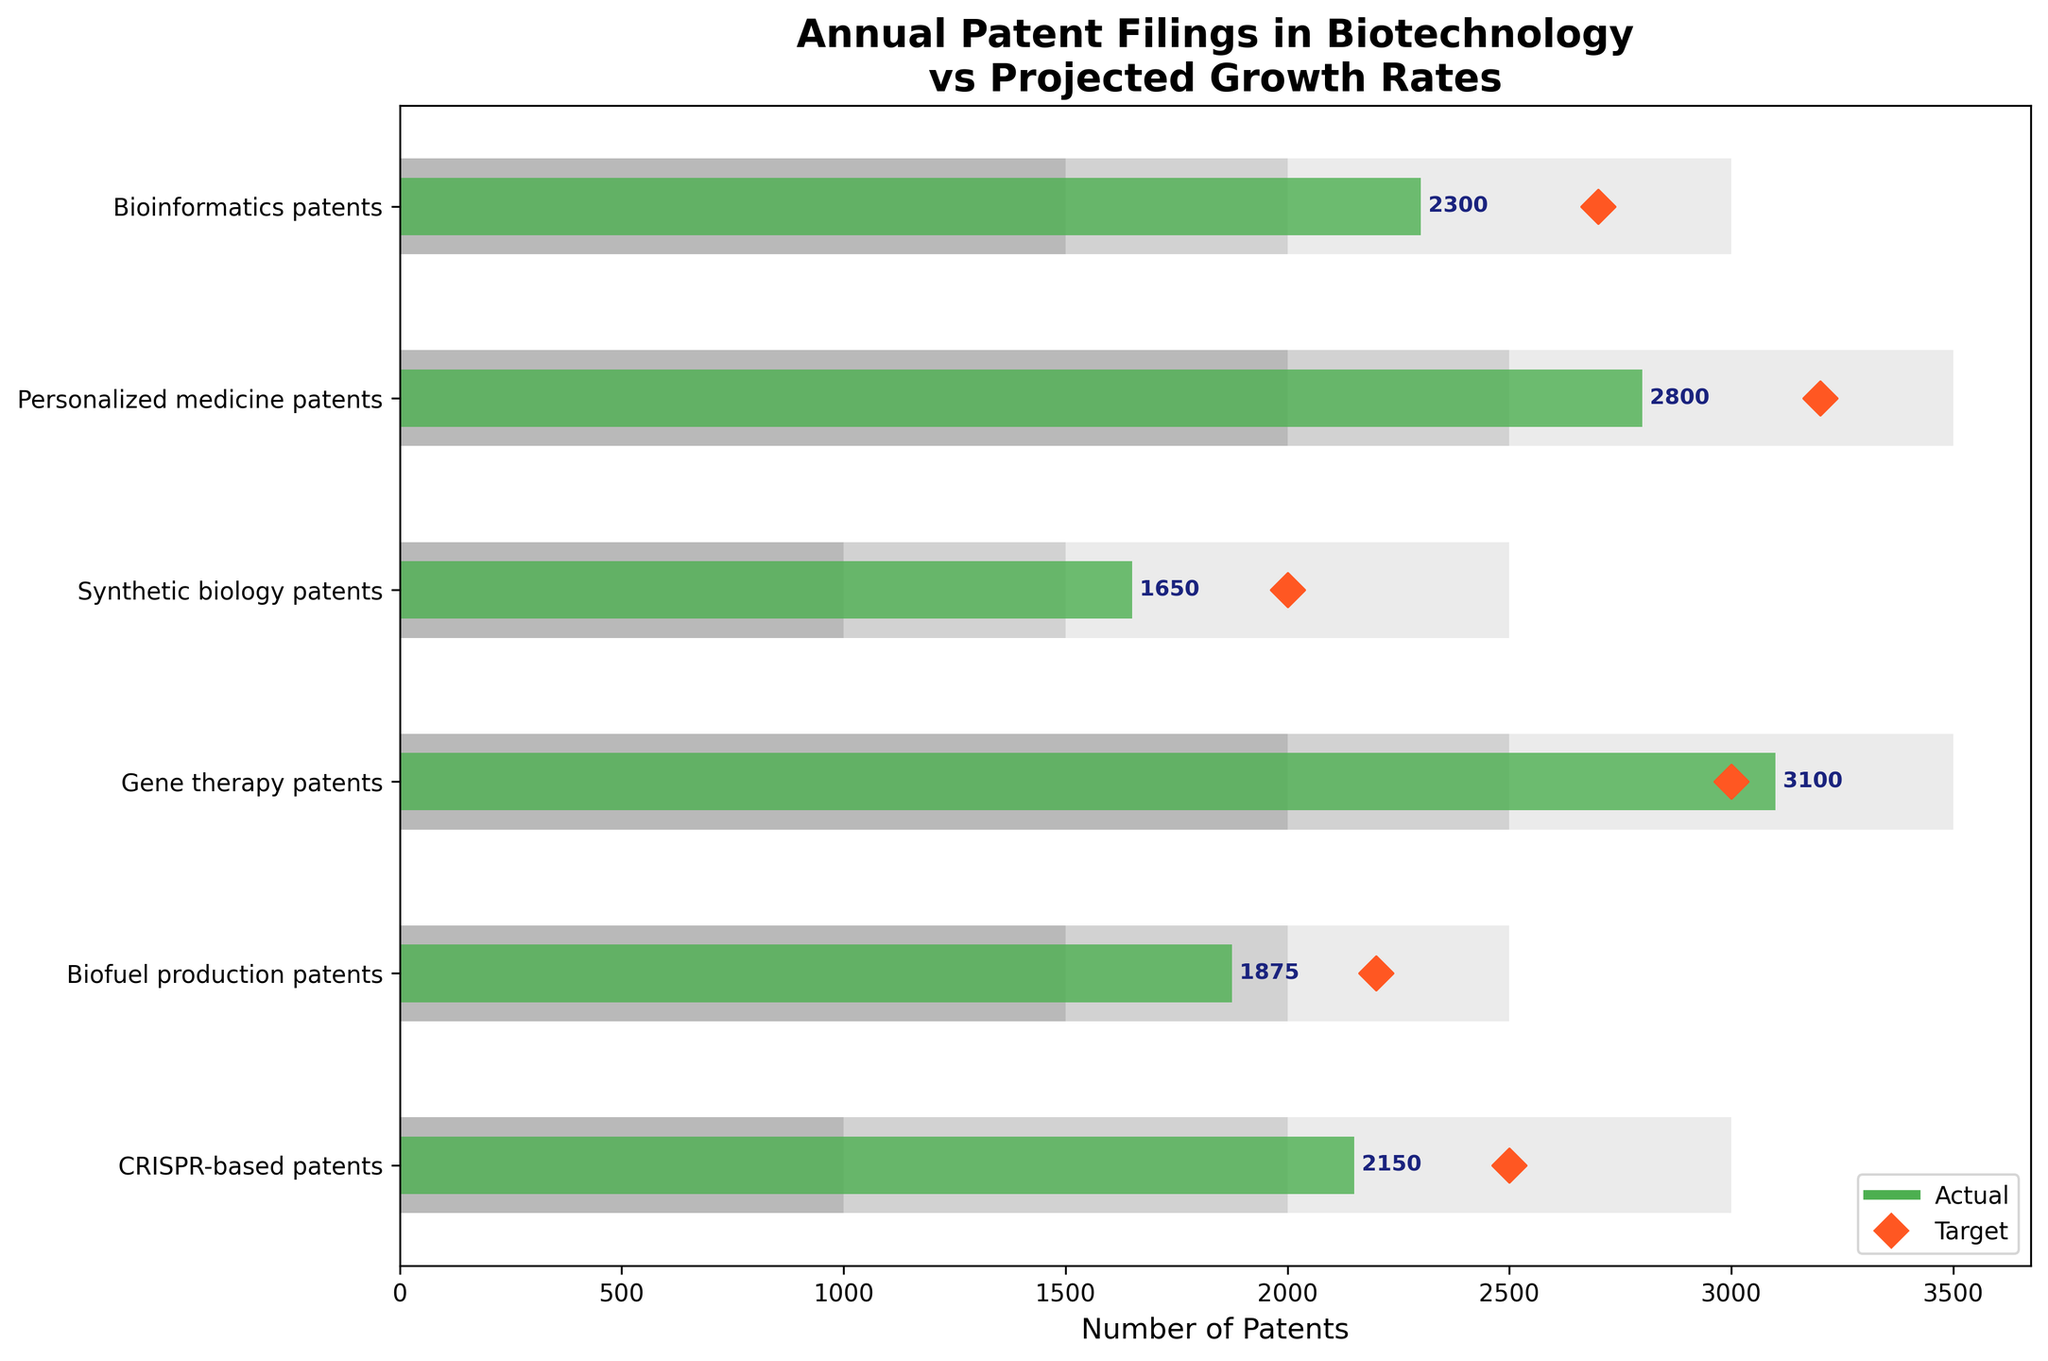what is the title of the chart? The title is usually placed at the top of the chart. Here, it clearly mentions the main focus: "Annual Patent Filings in Biotechnology vs Projected Growth Rates"
Answer: "Annual Patent Filings in Biotechnology vs Projected Growth Rates" what does the green bar represent in the bullet chart? By looking at the legend provided at the bottom right corner, the green bar is referred to as 'Actual'. This indicates the actual number of patents filed in each category.
Answer: Actual number of patents how many categories are compared in the chart? Vertically, we can count the number of categories labeled on the y-axis. The categories listed are CRISPR-based patents, Biofuel production patents, Gene therapy patents, Synthetic biology patents, Personalized medicine patents, and Bioinformatics patents.
Answer: 6 what’s the purpose of the diamond markers in the chart? Referring to the legend, the diamond markers indicate 'Target' values, which represent the projected number of patents expected for each category.
Answer: Target values which category has surpassed its target value? By examining where the green bar exceeds the diamond marker, it's clear that 'Gene therapy patents' has surpassed its target (3100 actual versus a 3000 target).
Answer: Gene therapy patents which category shows the largest difference between the actual and target values? By visually comparing the distances between the ends of the green bars and the diamond markers, the 'Personalized medicine patents' show the largest difference (2800 actual vs 3200 target, a 400 difference).
Answer: Personalized medicine patents what is the range for Bioinformatics patents? Analyzing the stacked background bars for 'Bioinformatics patents', the ranges are as follows: the darkest segment up to 1500, the middle segment up to 2000, and the lightest segment up to 3000.
Answer: 1500, 2000, 3000 which category has the least number of actual patents filed? By observing the lengths of the green bars horizontally, 'Synthetic biology patents' has the shortest green bar with an actual value of 1650.
Answer: Synthetic biology patents which categories have actual patent filings below their target values? Comparing the green bars to the diamond markers for each category, the following fall short: 'CRISPR-based patents', 'Biofuel production patents', 'Synthetic biology patents', 'Personalized medicine patents', 'Bioinformatics patents'.
Answer: CRISPR-based patents, Biofuel production patents, Synthetic biology patents, Personalized medicine patents, Bioinformatics patents what's the total actual number of patents filed across all categories? Summing the actual values from every category: 2150 + 1875 + 3100 + 1650 + 2800 + 2300 = 13875.
Answer: 13875 